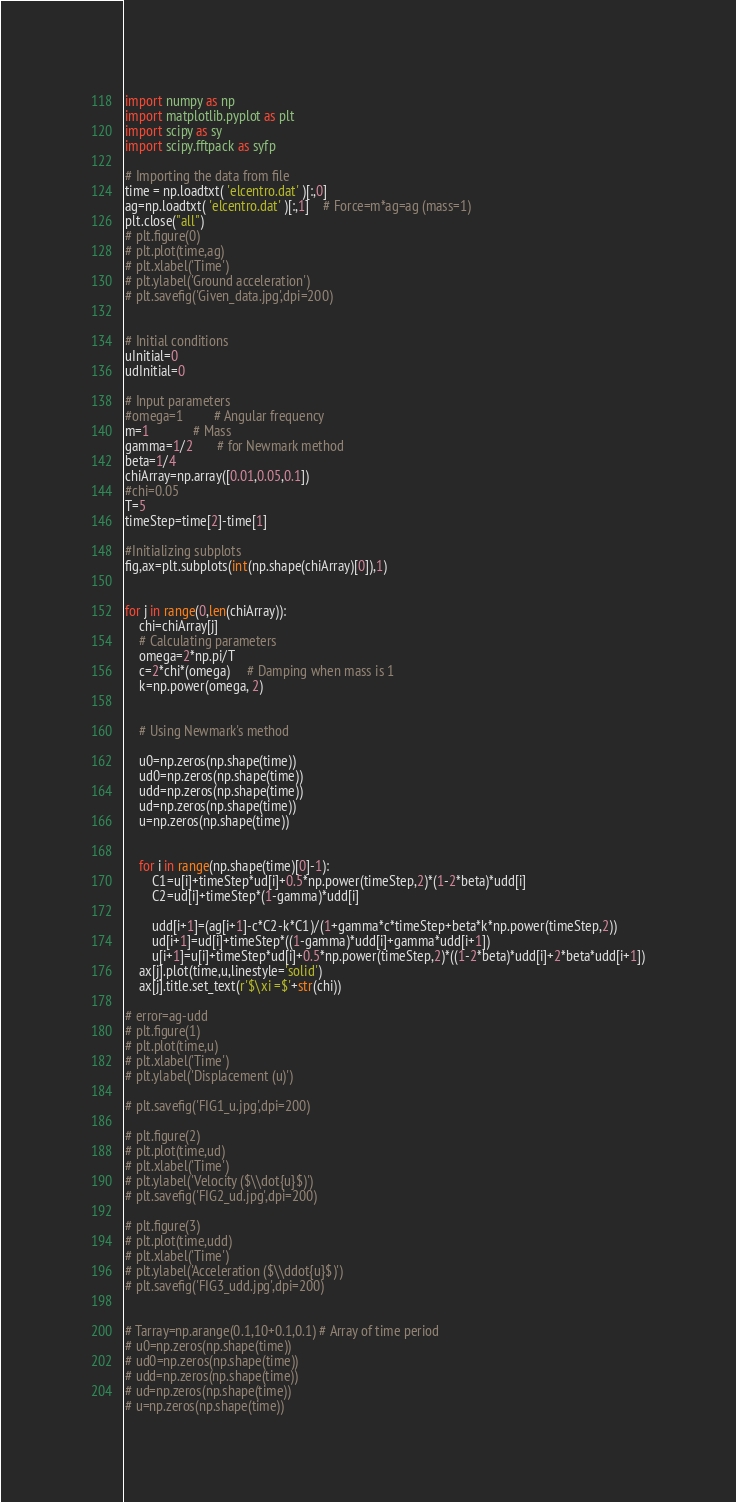Convert code to text. <code><loc_0><loc_0><loc_500><loc_500><_Python_>import numpy as np
import matplotlib.pyplot as plt
import scipy as sy
import scipy.fftpack as syfp

# Importing the data from file
time = np.loadtxt( 'elcentro.dat' )[:,0]
ag=np.loadtxt( 'elcentro.dat' )[:,1]    # Force=m*ag=ag (mass=1)
plt.close("all")
# plt.figure(0)
# plt.plot(time,ag)
# plt.xlabel('Time')
# plt.ylabel('Ground acceleration')
# plt.savefig('Given_data.jpg',dpi=200)


# Initial conditions
uInitial=0
udInitial=0

# Input parameters
#omega=1         # Angular frequency
m=1             # Mass
gamma=1/2       # for Newmark method
beta=1/4 
chiArray=np.array([0.01,0.05,0.1]) 
#chi=0.05
T=5
timeStep=time[2]-time[1]

#Initializing subplots
fig,ax=plt.subplots(int(np.shape(chiArray)[0]),1)


for j in range(0,len(chiArray)):
    chi=chiArray[j]
    # Calculating parameters
    omega=2*np.pi/T
    c=2*chi*(omega)     # Damping when mass is 1
    k=np.power(omega, 2)
    
    
    # Using Newmark's method
    
    u0=np.zeros(np.shape(time))
    ud0=np.zeros(np.shape(time))
    udd=np.zeros(np.shape(time))
    ud=np.zeros(np.shape(time))
    u=np.zeros(np.shape(time))
    

    for i in range(np.shape(time)[0]-1):
        C1=u[i]+timeStep*ud[i]+0.5*np.power(timeStep,2)*(1-2*beta)*udd[i]
        C2=ud[i]+timeStep*(1-gamma)*udd[i]
        
        udd[i+1]=(ag[i+1]-c*C2-k*C1)/(1+gamma*c*timeStep+beta*k*np.power(timeStep,2))
        ud[i+1]=ud[i]+timeStep*((1-gamma)*udd[i]+gamma*udd[i+1])
        u[i+1]=u[i]+timeStep*ud[i]+0.5*np.power(timeStep,2)*((1-2*beta)*udd[i]+2*beta*udd[i+1])
    ax[j].plot(time,u,linestyle='solid') 
    ax[j].title.set_text(r'$\xi =$'+str(chi))

# error=ag-udd
# plt.figure(1)
# plt.plot(time,u)
# plt.xlabel('Time')
# plt.ylabel('Displacement (u)')  

# plt.savefig('FIG1_u.jpg',dpi=200)

# plt.figure(2)
# plt.plot(time,ud)
# plt.xlabel('Time')
# plt.ylabel('Velocity ($\\dot{u}$)')
# plt.savefig('FIG2_ud.jpg',dpi=200)

# plt.figure(3)
# plt.plot(time,udd)
# plt.xlabel('Time')
# plt.ylabel('Acceleration ($\\ddot{u}$)')
# plt.savefig('FIG3_udd.jpg',dpi=200)


# Tarray=np.arange(0.1,10+0.1,0.1) # Array of time period
# u0=np.zeros(np.shape(time))
# ud0=np.zeros(np.shape(time))
# udd=np.zeros(np.shape(time))
# ud=np.zeros(np.shape(time))
# u=np.zeros(np.shape(time))
</code> 